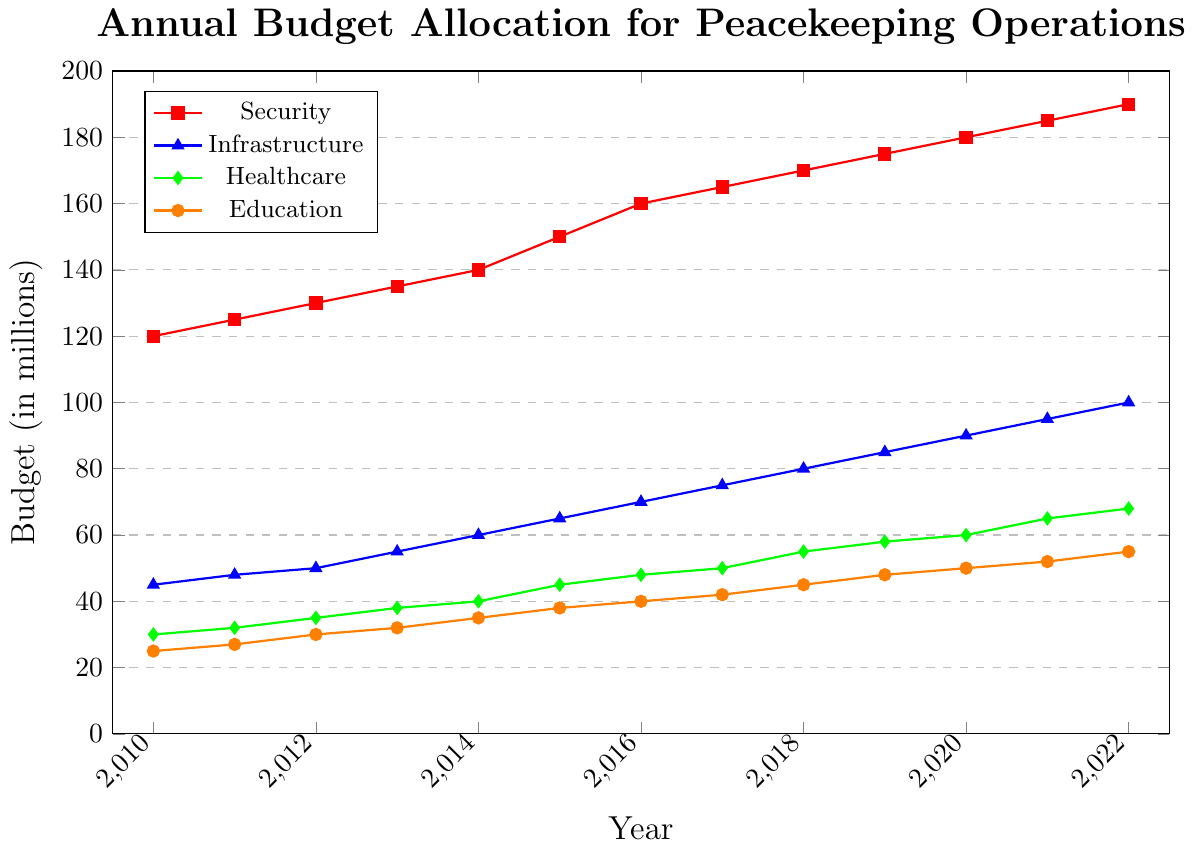What was the budget allocation for Healthcare and Education combined in 2014? In 2014, the budget for Healthcare was 40 million, and for Education it was 35 million. Combining these gives us 40 + 35 = 75 million.
Answer: 75 million In which year did the Security budget surpass 150 million? The Security budget surpassed 150 million in 2016 where it was recorded at 160 million.
Answer: 2016 What is the difference in budget allocation for Infrastructure between 2012 and 2022? In 2012, the Infrastructure budget was 50 million, and in 2022 it was 100 million. The difference is 100 - 50 = 50 million.
Answer: 50 million Which sector saw the greatest absolute increase in budget from 2010 to 2022? To find the greatest absolute increase, subtract the 2010 budget from the 2022 budget for each sector: 
- Security: 190 - 120 = 70 million 
- Infrastructure: 100 - 45 = 55 million 
- Healthcare: 68 - 30 = 38 million 
- Education: 55 - 25 = 30 million 
The greatest increase was in the Security sector with an increase of 70 million.
Answer: Security How many times during the period from 2010 to 2022 did the Education budget increase? Observing the line for Education (orange with circular markers), it increased every year from 25 million in 2010 to 55 million in 2022. This indicates it increased each year for a total of 12 increases.
Answer: 12 times In which year did the Healthcare budget first exceed the Education budget by more than 8 million? Reviewing the budgets year by year:
- In 2010, Healthcare was 30 and Education was 25 (difference 5 million)
- In 2011, Healthcare was 32 and Education was 27 (difference 5 million)
- In 2012, Healthcare was 35 and Education was 30 (difference 5 million)
- In 2013, Healthcare was 38 and Education was 32 (difference 6 million)
- In 2014, Healthcare was 40 and Education was 35 (difference 5 million)
- In 2015, Healthcare was 45 and Education was 38 (difference 7 million)
- In 2016, Healthcare was 48 and Education was 40 (difference 8 million)
- In 2017, Healthcare was 50 and Education was 42 (difference 8 million)
- In 2018, Healthcare was 55 and Education was 45 (difference 10 million)
Thus, in 2018, the Healthcare budget first exceeded the Education budget by more than 8 million.
Answer: 2018 Comparing the slope of the lines between 2014 to 2017, which sector had the steepest increase in budget allocation? To compare the slopes between 2014 and 2017, we calculate the change in budget:
- Security: 165 - 140 = 25 million
- Infrastructure: 75 - 60 = 15 million
- Healthcare: 50 - 40 = 10 million
- Education: 42 - 35 = 7 million
The Security sector had the steepest increase with a change of 25 million.
Answer: Security What is the total budget allocated for all sectors in 2020? To find the total budget in 2020, sum the budgets for all sectors:
Security (180) + Infrastructure (90) + Healthcare (60) + Education (50) = 380 million.
Answer: 380 million Which year marked the highest budget increase for Infrastructure compared to the previous year? Comparing the annual increases in Infrastructure budgets:
- 2011: 48 - 45 = 3 million
- 2012: 50 - 48 = 2 million
- 2013: 55 - 50 = 5 million
- 2014: 60 - 55 = 5 million
- 2015: 65 - 60 = 5 million
- 2016: 70 - 65 = 5 million
- 2017: 75 - 70 = 5 million
- 2018: 80 - 75 = 5 million
- 2019: 85 - 80 = 5 million
- 2020: 90 - 85 = 5 million
- 2021: 95 - 90 = 5 million
- 2022: 100 - 95 = 5 مليون
Years 2013-2022 all saw equal highest increases of 5 million.
Answer: 2013 and every subsequent year Identify the year with the smallest increase in the Education budget. The annual comparison of Education budget increase:
- 2011: 27 - 25 = 2 million
- 2012: 30 - 27 = 3 million
- 2013: 32 - 30 = 2 million
- 2014: 35 - 32 = 3 million
- 2015: 38 - 35 = 3 million
- 2016: 40 - 38 = 2 million
- 2017: 42 - 40 = 2 million
- 2018: 45 - 42 = 3 million
- 2019: 48 - 45 = 3 million
- 2020: 50 - 48 = 2 million
- 2021: 52 - 50 = 2 million
- 2022: 55 - 52 = 3 million
The smallest increase occurred in 2011, 2013, 2016, 2017, 2020, and 2021, all with an increase of 2 million.
Answer: 2011, 2013, 2016, 2017, 2020, and 2021 